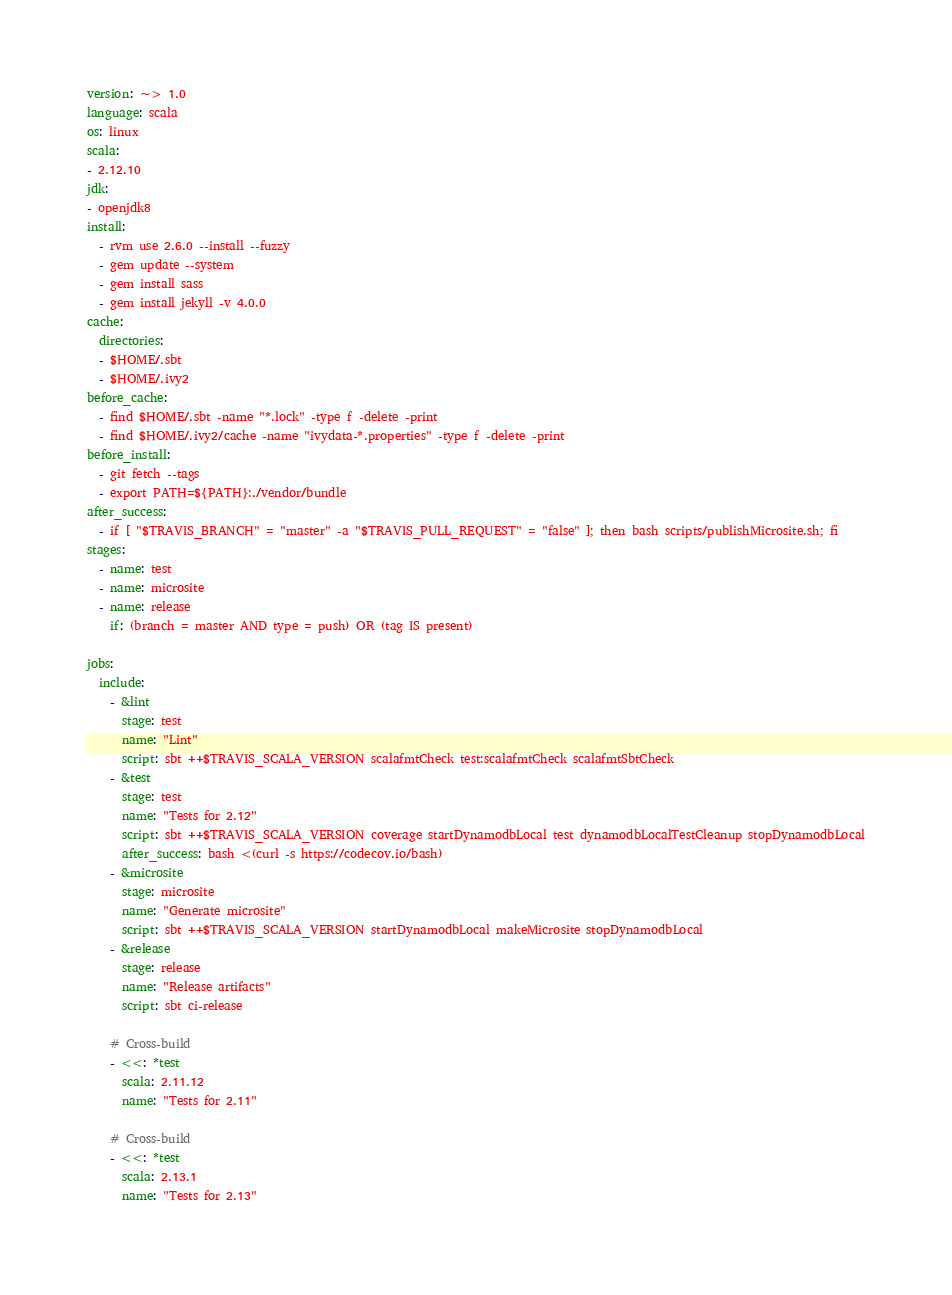<code> <loc_0><loc_0><loc_500><loc_500><_YAML_>version: ~> 1.0
language: scala
os: linux
scala:
- 2.12.10
jdk:
- openjdk8
install:
  - rvm use 2.6.0 --install --fuzzy
  - gem update --system
  - gem install sass
  - gem install jekyll -v 4.0.0
cache:
  directories:
  - $HOME/.sbt
  - $HOME/.ivy2
before_cache:
  - find $HOME/.sbt -name "*.lock" -type f -delete -print
  - find $HOME/.ivy2/cache -name "ivydata-*.properties" -type f -delete -print
before_install:
  - git fetch --tags
  - export PATH=${PATH}:./vendor/bundle
after_success:
  - if [ "$TRAVIS_BRANCH" = "master" -a "$TRAVIS_PULL_REQUEST" = "false" ]; then bash scripts/publishMicrosite.sh; fi
stages:
  - name: test
  - name: microsite
  - name: release
    if: (branch = master AND type = push) OR (tag IS present)

jobs:
  include:
    - &lint
      stage: test
      name: "Lint"
      script: sbt ++$TRAVIS_SCALA_VERSION scalafmtCheck test:scalafmtCheck scalafmtSbtCheck
    - &test
      stage: test
      name: "Tests for 2.12"
      script: sbt ++$TRAVIS_SCALA_VERSION coverage startDynamodbLocal test dynamodbLocalTestCleanup stopDynamodbLocal
      after_success: bash <(curl -s https://codecov.io/bash)
    - &microsite
      stage: microsite
      name: "Generate microsite"
      script: sbt ++$TRAVIS_SCALA_VERSION startDynamodbLocal makeMicrosite stopDynamodbLocal
    - &release
      stage: release
      name: "Release artifacts"
      script: sbt ci-release

    # Cross-build
    - <<: *test
      scala: 2.11.12
      name: "Tests for 2.11"

    # Cross-build
    - <<: *test
      scala: 2.13.1
      name: "Tests for 2.13"
</code> 